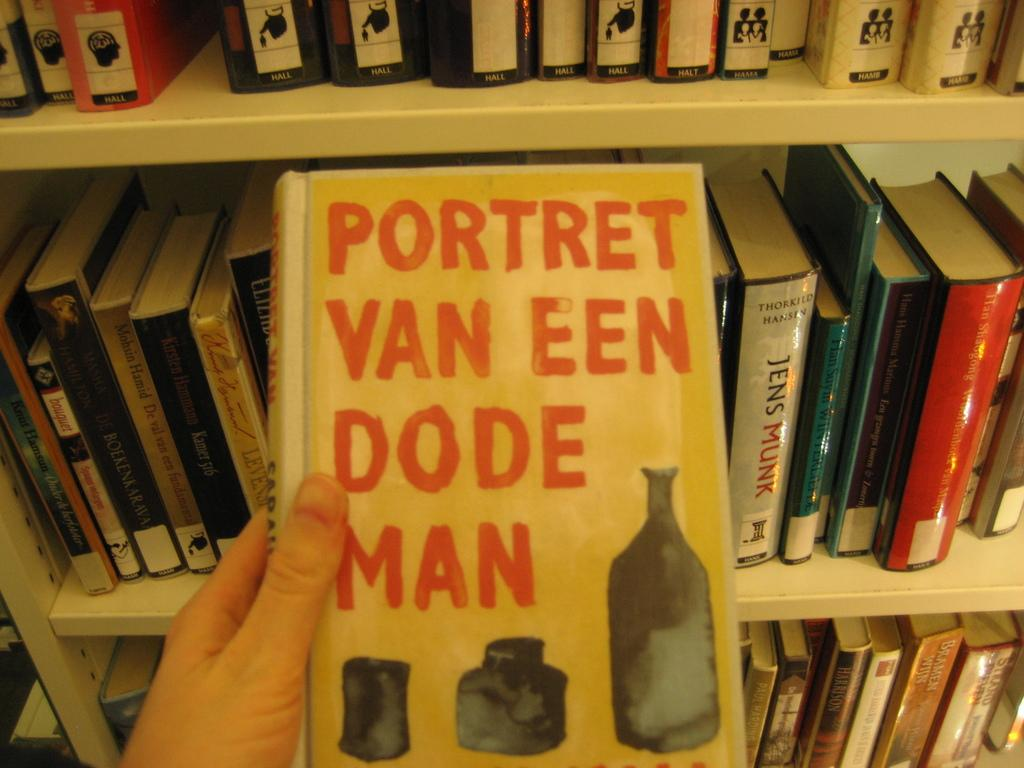Provide a one-sentence caption for the provided image. A yellow book of Portret Van Een Dode Man. 